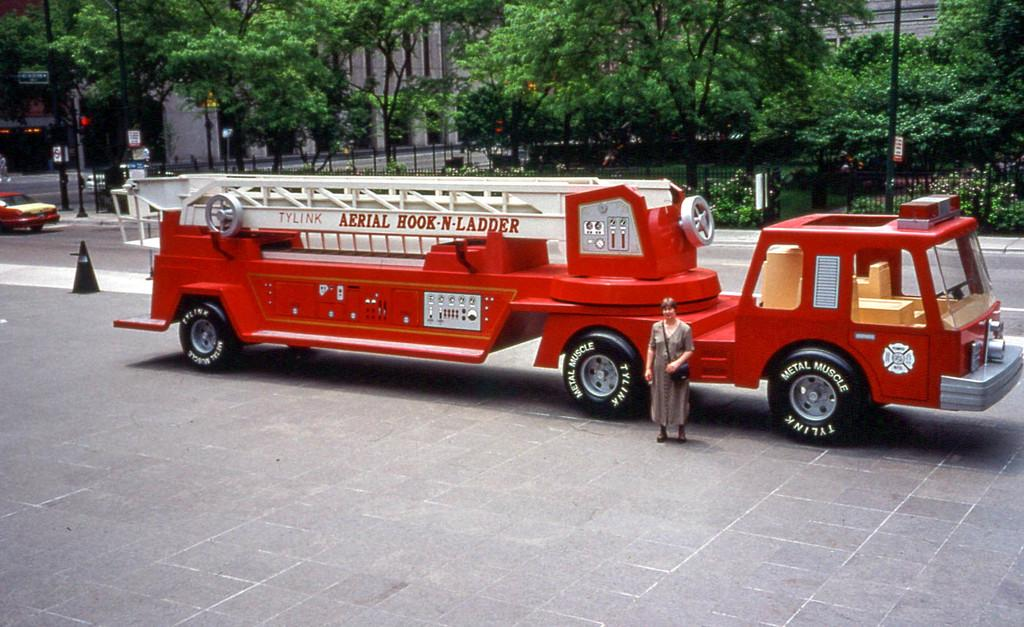What is the main subject of the image? The main subject of the image is a fire engine. Can you describe any other elements in the image? Yes, there is a woman standing in the image, and she is wearing a dress. What type of natural environment is visible in the image? There are trees in the image. How many brothers does the woman in the image have? There is no information about the woman's brothers in the image, so it cannot be determined. 